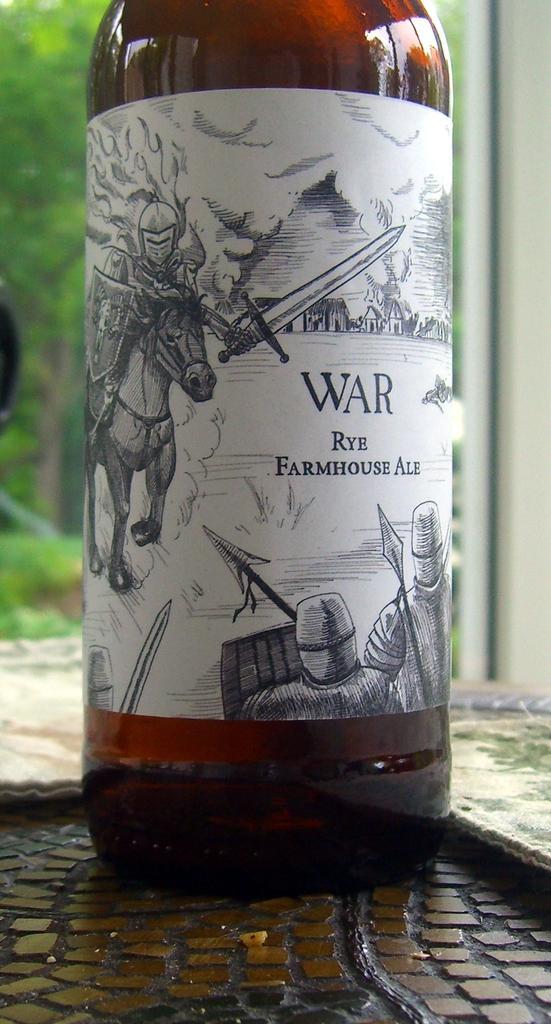In one or two sentences, can you explain what this image depicts? In the center of the image we can see one table. On the table, we can see one bottle. On the bottle, we can see one horse, few people, some text and a few other objects. In the background there is a glass window and a few other objects. Through the glass window, we can see trees and a few other objects. 